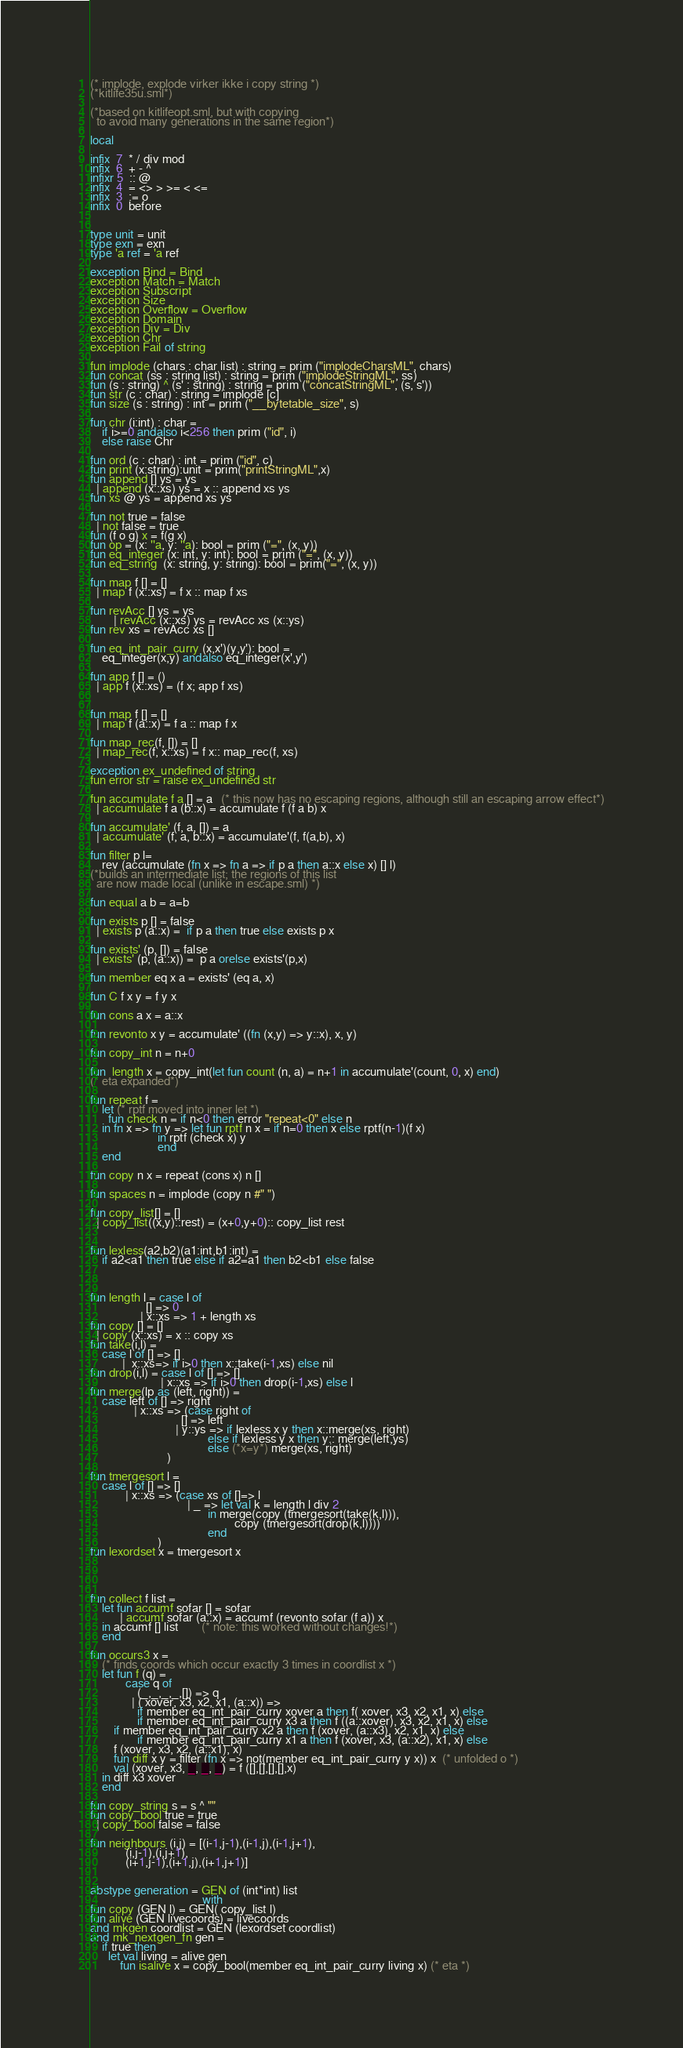<code> <loc_0><loc_0><loc_500><loc_500><_SML_>(* implode, explode virker ikke i copy string *)
(*kitlife35u.sml*)

(*based on kitlifeopt.sml, but with copying
  to avoid many generations in the same region*)

local

infix  7  * / div mod
infix  6  + - ^
infixr 5  :: @
infix  4  = <> > >= < <=
infix  3  := o
infix  0  before


type unit = unit
type exn = exn
type 'a ref = 'a ref

exception Bind = Bind
exception Match = Match
exception Subscript
exception Size
exception Overflow = Overflow
exception Domain
exception Div = Div
exception Chr
exception Fail of string

fun implode (chars : char list) : string = prim ("implodeCharsML", chars)
fun concat (ss : string list) : string = prim ("implodeStringML", ss)
fun (s : string) ^ (s' : string) : string = prim ("concatStringML", (s, s'))
fun str (c : char) : string = implode [c]
fun size (s : string) : int = prim ("__bytetable_size", s)

fun chr (i:int) : char =
    if i>=0 andalso i<256 then prim ("id", i)
    else raise Chr

fun ord (c : char) : int = prim ("id", c)
fun print (x:string):unit = prim("printStringML",x)
fun append [] ys = ys
  | append (x::xs) ys = x :: append xs ys
fun xs @ ys = append xs ys

fun not true = false
  | not false = true
fun (f o g) x = f(g x)
fun op = (x: ''a, y: ''a): bool = prim ("=", (x, y))
fun eq_integer (x: int, y: int): bool = prim ("=", (x, y))
fun eq_string  (x: string, y: string): bool = prim("=", (x, y))

fun map f [] = []
  | map f (x::xs) = f x :: map f xs

fun revAcc [] ys = ys
        | revAcc (x::xs) ys = revAcc xs (x::ys)
fun rev xs = revAcc xs []

fun eq_int_pair_curry (x,x')(y,y'): bool =
    eq_integer(x,y) andalso eq_integer(x',y')

fun app f [] = ()
  | app f (x::xs) = (f x; app f xs)


fun map f [] = []
  | map f (a::x) = f a :: map f x

fun map_rec(f, []) = []
  | map_rec(f, x::xs) = f x:: map_rec(f, xs)

exception ex_undefined of string
fun error str = raise ex_undefined str

fun accumulate f a [] = a   (* this now has no escaping regions, although still an escaping arrow effect*)
  | accumulate f a (b::x) = accumulate f (f a b) x

fun accumulate' (f, a, []) = a
  | accumulate' (f, a, b::x) = accumulate'(f, f(a,b), x)

fun filter p l=
    rev (accumulate (fn x => fn a => if p a then a::x else x) [] l)
(*builds an intermediate list; the regions of this list
  are now made local (unlike in escape.sml) *)

fun equal a b = a=b

fun exists p [] = false
  | exists p (a::x) =  if p a then true else exists p x

fun exists' (p, []) = false
  | exists' (p, (a::x)) =  p a orelse exists'(p,x)

fun member eq x a = exists' (eq a, x)

fun C f x y = f y x

fun cons a x = a::x

fun revonto x y = accumulate' ((fn (x,y) => y::x), x, y)

fun copy_int n = n+0

fun  length x = copy_int(let fun count (n, a) = n+1 in accumulate'(count, 0, x) end)
(* eta expanded*)

fun repeat f =
    let (* rptf moved into inner let *)
      fun check n = if n<0 then error "repeat<0" else n
    in fn x => fn y => let fun rptf n x = if n=0 then x else rptf(n-1)(f x)
                       in rptf (check x) y
                       end
    end

fun copy n x = repeat (cons x) n []

fun spaces n = implode (copy n #" ")

fun copy_list[] = []
  | copy_list((x,y)::rest) = (x+0,y+0):: copy_list rest


fun lexless(a2,b2)(a1:int,b1:int) =
    if a2<a1 then true else if a2=a1 then b2<b1 else false



fun length l = case l of
                   [] => 0
                 | x::xs => 1 + length xs
fun copy [] = []
  | copy (x::xs) = x :: copy xs
fun take(i,l) =
    case l of [] => []
           |  x::xs=> if i>0 then x::take(i-1,xs) else nil
fun drop(i,l) = case l of [] => []
                        | x::xs => if i>0 then drop(i-1,xs) else l
fun merge(lp as (left, right)) =
    case left of [] => right
               | x::xs => (case right of
                               [] => left
                             | y::ys => if lexless x y then x::merge(xs, right)
                                        else if lexless y x then y:: merge(left,ys)
                                        else (*x=y*) merge(xs, right)
                          )

fun tmergesort l =
    case l of [] => []
            | x::xs => (case xs of []=> l
                                 | _ => let val k = length l div 2
                                        in merge(copy (tmergesort(take(k,l))),
                                                 copy (tmergesort(drop(k,l))))
                                        end
                       )
fun lexordset x = tmergesort x




fun collect f list =
    let fun accumf sofar [] = sofar
          | accumf sofar (a::x) = accumf (revonto sofar (f a)) x
    in accumf [] list        (* note: this worked without changes!*)
    end

fun occurs3 x =
    (* finds coords which occur exactly 3 times in coordlist x *)
    let fun f (q) =
            case q of
                (_,_,_,_,[]) => q
              | ( xover, x3, x2, x1, (a::x)) =>
                if member eq_int_pair_curry xover a then f( xover, x3, x2, x1, x) else
                if member eq_int_pair_curry x3 a then f ((a::xover), x3, x2, x1, x) else
		if member eq_int_pair_curry x2 a then f (xover, (a::x3), x2, x1, x) else
                if member eq_int_pair_curry x1 a then f (xover, x3, (a::x2), x1, x) else
		f (xover, x3, x2, (a::x1), x)
        fun diff x y = filter (fn x => not(member eq_int_pair_curry y x)) x  (* unfolded o *)
        val (xover, x3, _, _, _) = f ([],[],[],[],x)
    in diff x3 xover
    end

fun copy_string s = s ^ ""
fun copy_bool true = true
  | copy_bool false = false

fun neighbours (i,j) = [(i-1,j-1),(i-1,j),(i-1,j+1),
			(i,j-1),(i,j+1),
			(i+1,j-1),(i+1,j),(i+1,j+1)]


abstype generation = GEN of (int*int) list
                                      with
fun copy (GEN l) = GEN( copy_list l)
fun alive (GEN livecoords) = livecoords
and mkgen coordlist = GEN (lexordset coordlist)
and mk_nextgen_fn gen =
    if true then
      let val living = alive gen
          fun isalive x = copy_bool(member eq_int_pair_curry living x) (* eta *)</code> 